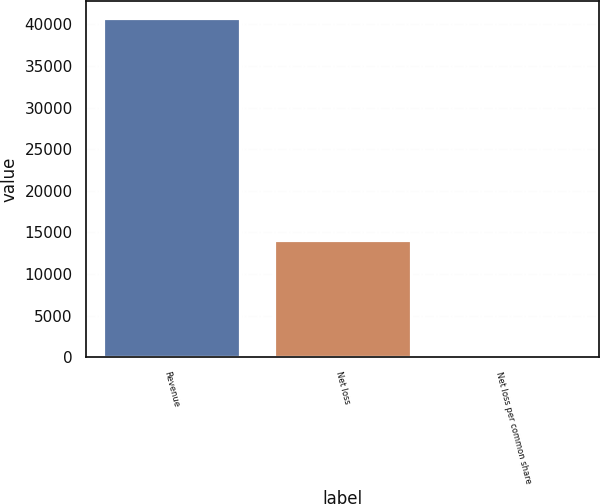<chart> <loc_0><loc_0><loc_500><loc_500><bar_chart><fcel>Revenue<fcel>Net loss<fcel>Net loss per common share<nl><fcel>40711<fcel>14076<fcel>0.54<nl></chart> 